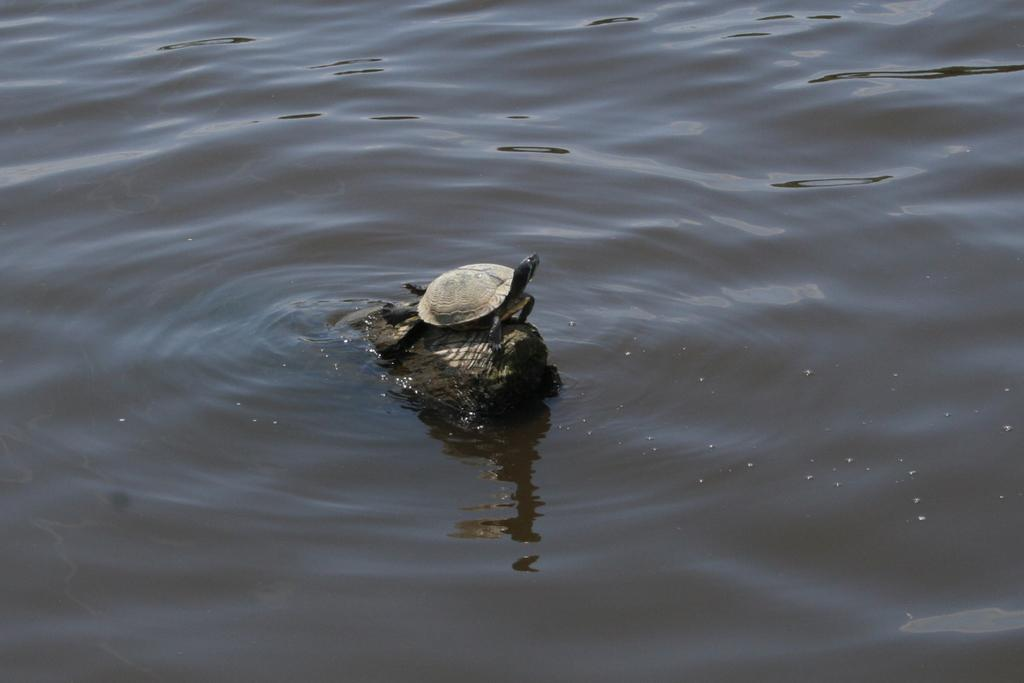What type of animal is in the image? There is a small turtle in the image. Where is the turtle located? The turtle is in a water pound. What is the mass of the effect that the turtle creates in the image? There is no effect created by the turtle in the image, and therefore no mass can be determined. 